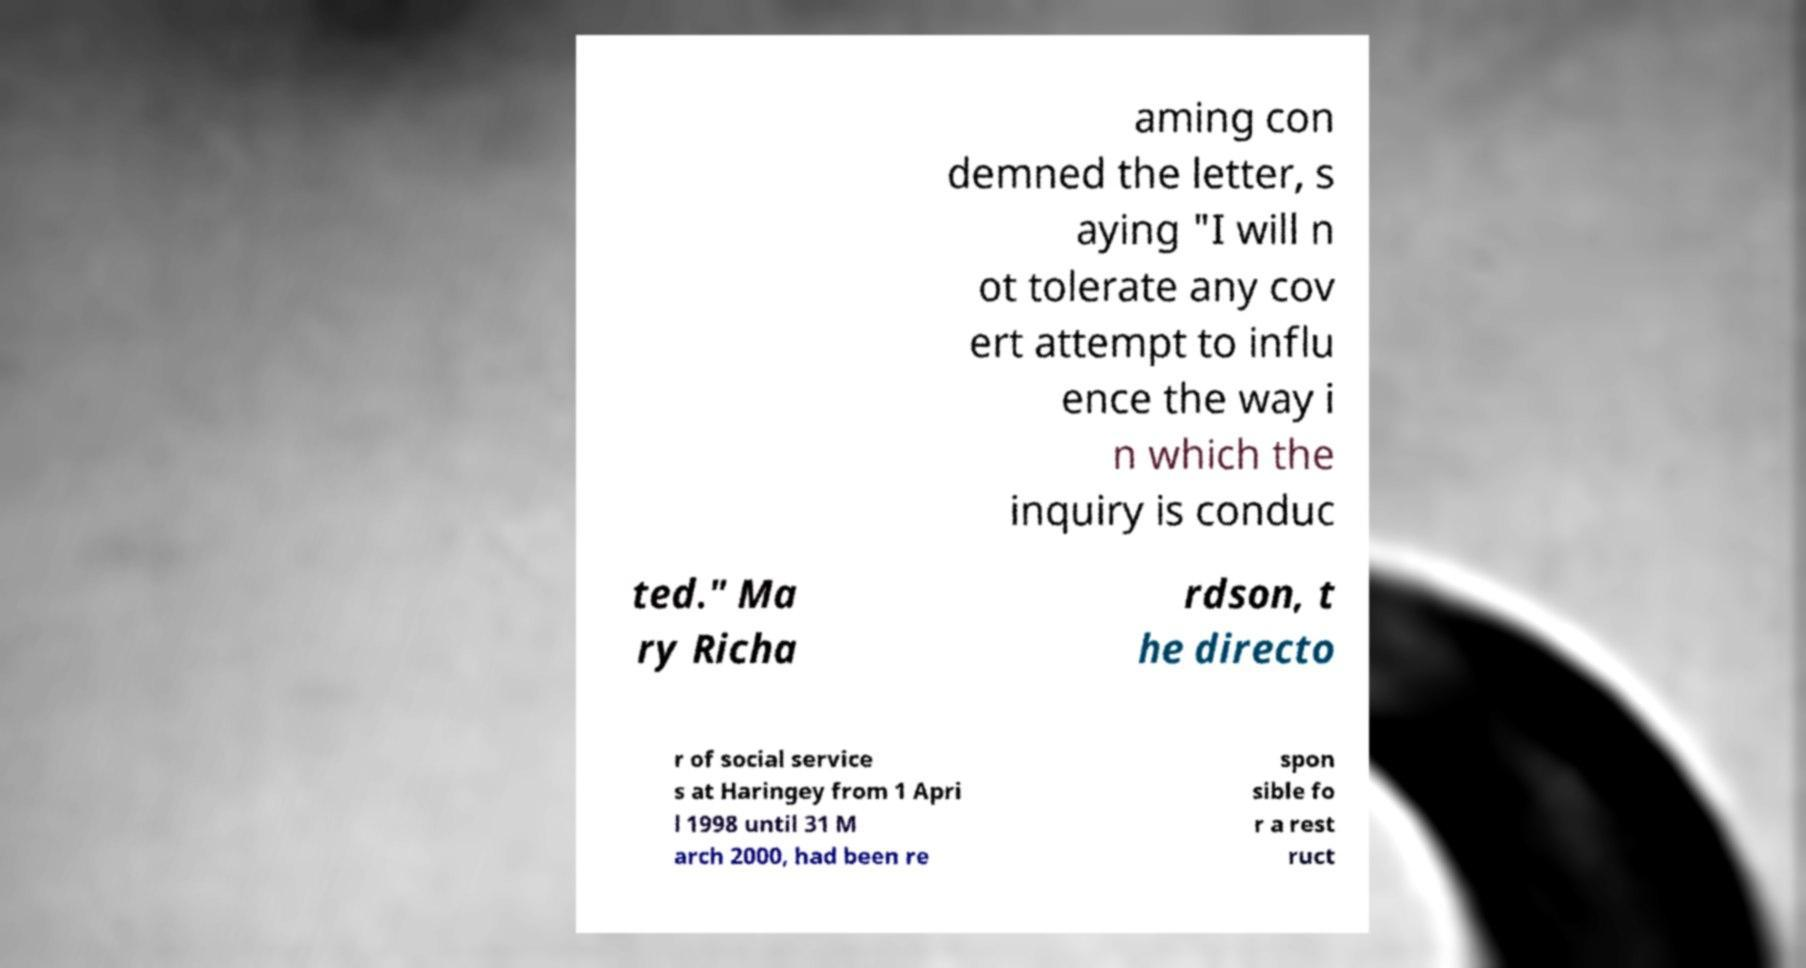Can you accurately transcribe the text from the provided image for me? aming con demned the letter, s aying "I will n ot tolerate any cov ert attempt to influ ence the way i n which the inquiry is conduc ted." Ma ry Richa rdson, t he directo r of social service s at Haringey from 1 Apri l 1998 until 31 M arch 2000, had been re spon sible fo r a rest ruct 